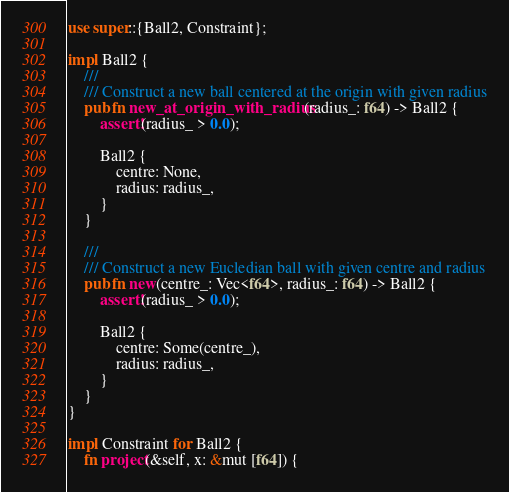Convert code to text. <code><loc_0><loc_0><loc_500><loc_500><_Rust_>use super::{Ball2, Constraint};

impl Ball2 {
    ///
    /// Construct a new ball centered at the origin with given radius
    pub fn new_at_origin_with_radius(radius_: f64) -> Ball2 {
        assert!(radius_ > 0.0);

        Ball2 {
            centre: None,
            radius: radius_,
        }
    }

    ///
    /// Construct a new Eucledian ball with given centre and radius
    pub fn new(centre_: Vec<f64>, radius_: f64) -> Ball2 {
        assert!(radius_ > 0.0);

        Ball2 {
            centre: Some(centre_),
            radius: radius_,
        }
    }
}

impl Constraint for Ball2 {
    fn project(&self, x: &mut [f64]) {</code> 